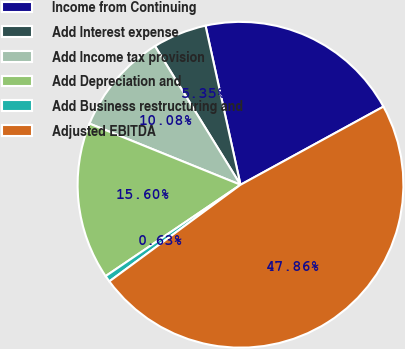<chart> <loc_0><loc_0><loc_500><loc_500><pie_chart><fcel>Income from Continuing<fcel>Add Interest expense<fcel>Add Income tax provision<fcel>Add Depreciation and<fcel>Add Business restructuring and<fcel>Adjusted EBITDA<nl><fcel>20.48%<fcel>5.35%<fcel>10.08%<fcel>15.6%<fcel>0.63%<fcel>47.86%<nl></chart> 